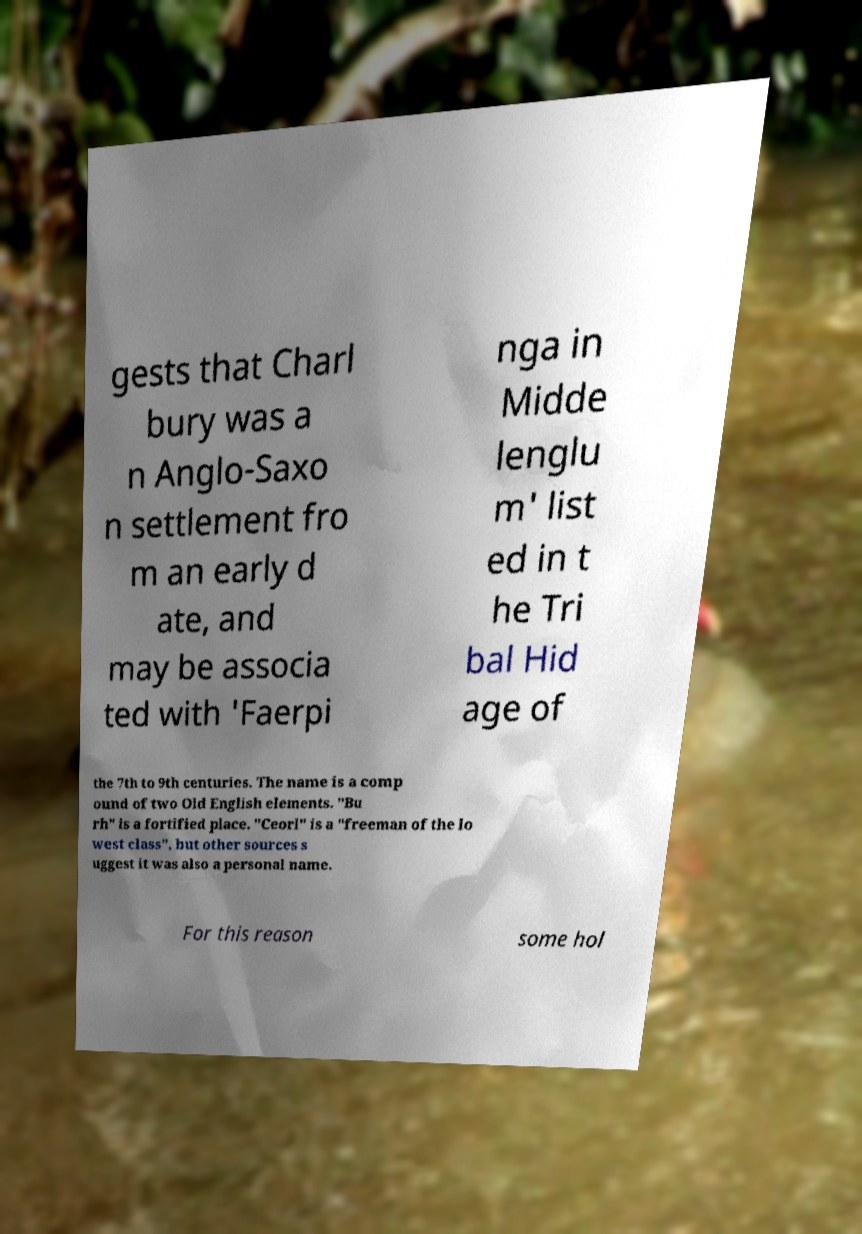There's text embedded in this image that I need extracted. Can you transcribe it verbatim? gests that Charl bury was a n Anglo-Saxo n settlement fro m an early d ate, and may be associa ted with 'Faerpi nga in Midde lenglu m' list ed in t he Tri bal Hid age of the 7th to 9th centuries. The name is a comp ound of two Old English elements. "Bu rh" is a fortified place. "Ceorl" is a "freeman of the lo west class", but other sources s uggest it was also a personal name. For this reason some hol 